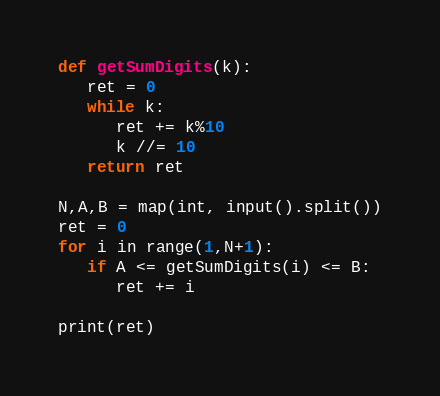Convert code to text. <code><loc_0><loc_0><loc_500><loc_500><_Python_>def getSumDigits(k):
   ret = 0
   while k:
      ret += k%10
      k //= 10
   return ret

N,A,B = map(int, input().split())
ret = 0
for i in range(1,N+1):
   if A <= getSumDigits(i) <= B:
      ret += i

print(ret)</code> 